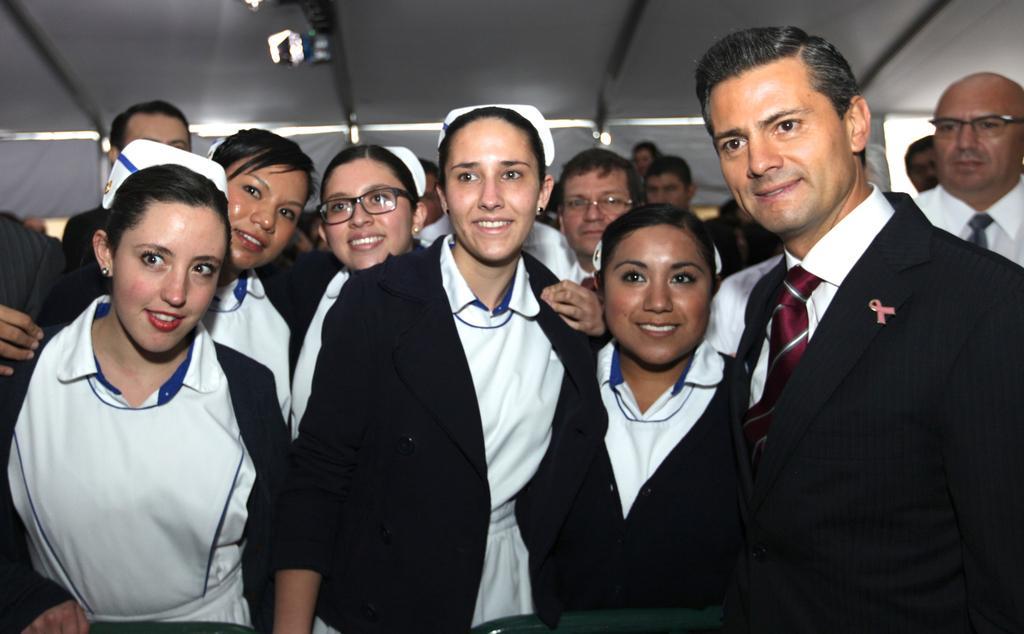Could you give a brief overview of what you see in this image? In this picture there are group of people standing and smiling. At the top it looks like a tent and there are lights. In the foreground there are chairs. 